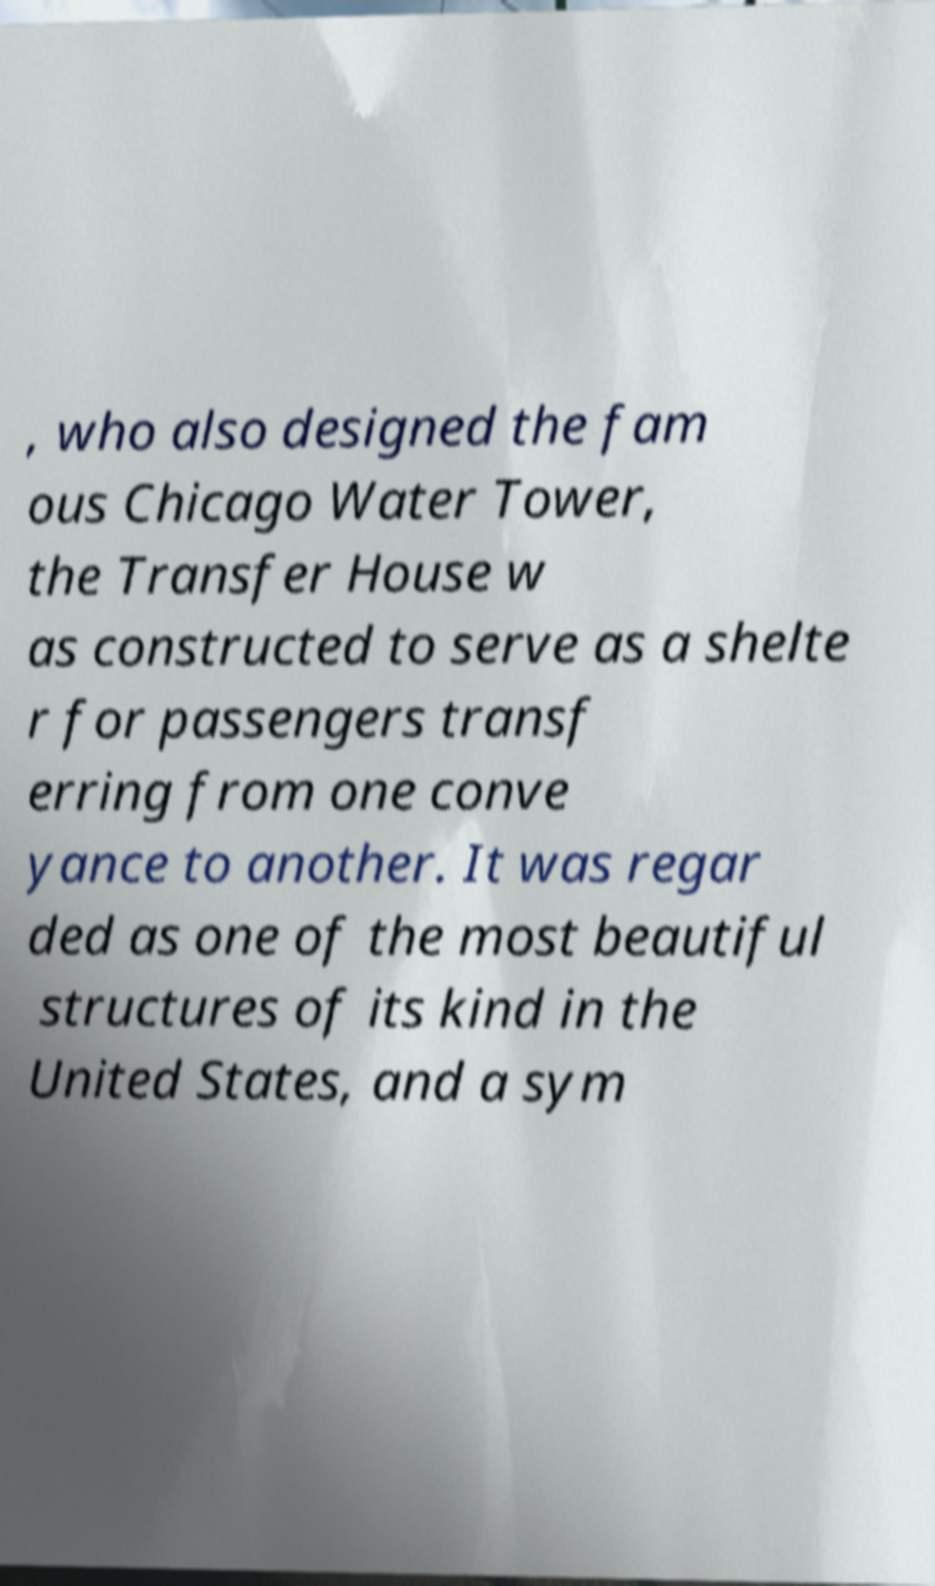Could you extract and type out the text from this image? , who also designed the fam ous Chicago Water Tower, the Transfer House w as constructed to serve as a shelte r for passengers transf erring from one conve yance to another. It was regar ded as one of the most beautiful structures of its kind in the United States, and a sym 